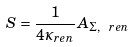Convert formula to latex. <formula><loc_0><loc_0><loc_500><loc_500>S = \frac { 1 } { 4 \kappa _ { r e n } } A _ { \Sigma , \ r e n }</formula> 